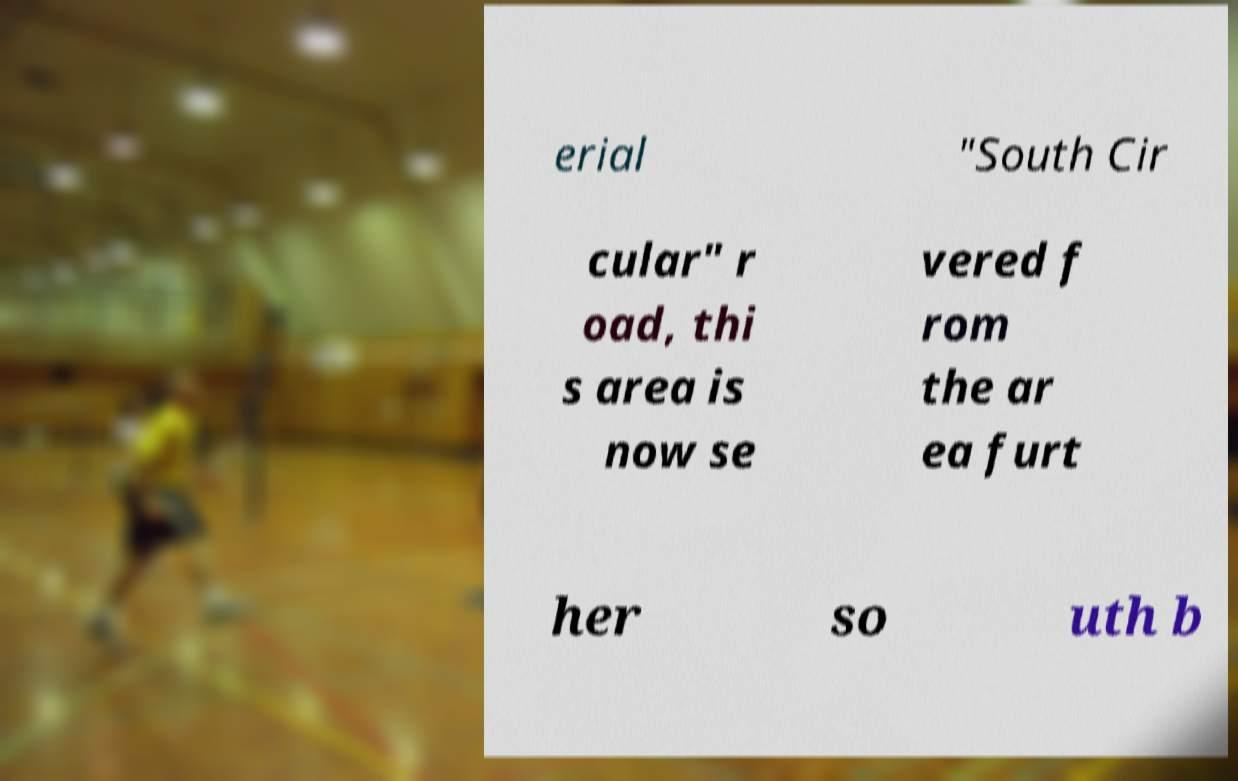Can you accurately transcribe the text from the provided image for me? erial "South Cir cular" r oad, thi s area is now se vered f rom the ar ea furt her so uth b 